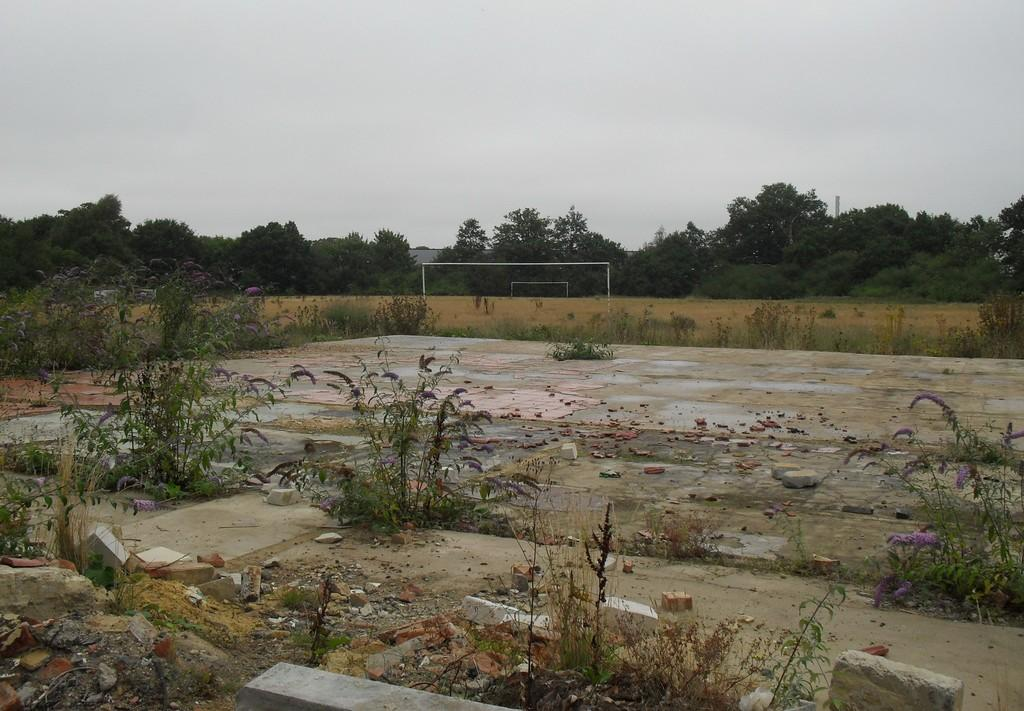What type of land surface is visible in the image? There is a land surface with plants in the image. What can be found on the land surface? There are broken stones on the land surface. What can be seen in the background of the image? There is a playground and many trees visible in the background. What else is visible in the background of the image? The sky is visible in the background of the image. What type of shoes can be seen hanging from the trees in the image? There are no shoes hanging from the trees in the image; only the playground, trees, and sky are visible in the background. 